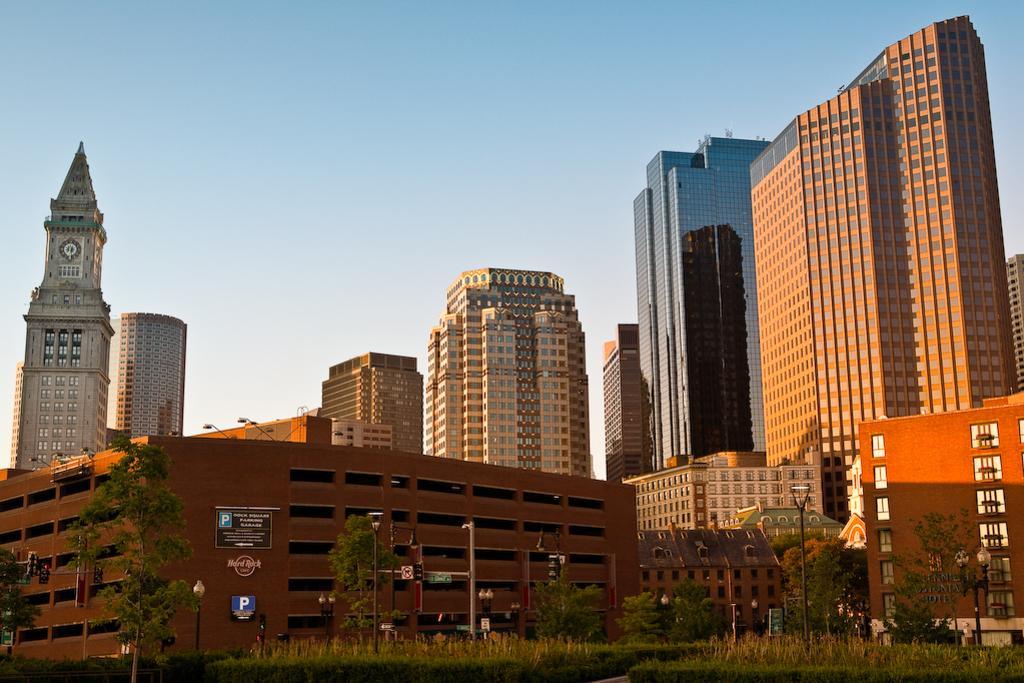Please provide a concise description of this image. In the foreground of the picture there are trees, street lights, plants, path and buildings. In the middle of the picture there are buildings. At the top it is sky. 